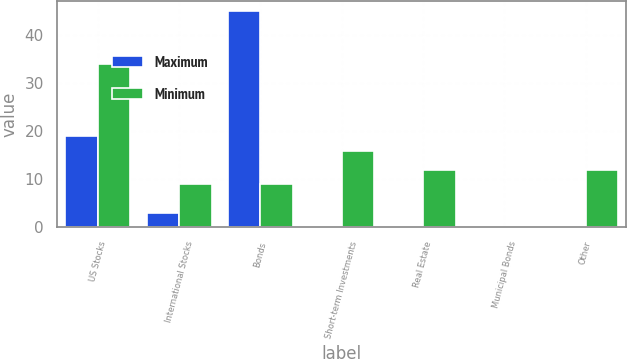Convert chart to OTSL. <chart><loc_0><loc_0><loc_500><loc_500><stacked_bar_chart><ecel><fcel>US Stocks<fcel>International Stocks<fcel>Bonds<fcel>Short-term Investments<fcel>Real Estate<fcel>Municipal Bonds<fcel>Other<nl><fcel>Maximum<fcel>19<fcel>3<fcel>45<fcel>0<fcel>0<fcel>0<fcel>0<nl><fcel>Minimum<fcel>34<fcel>9<fcel>9<fcel>16<fcel>12<fcel>0<fcel>12<nl></chart> 